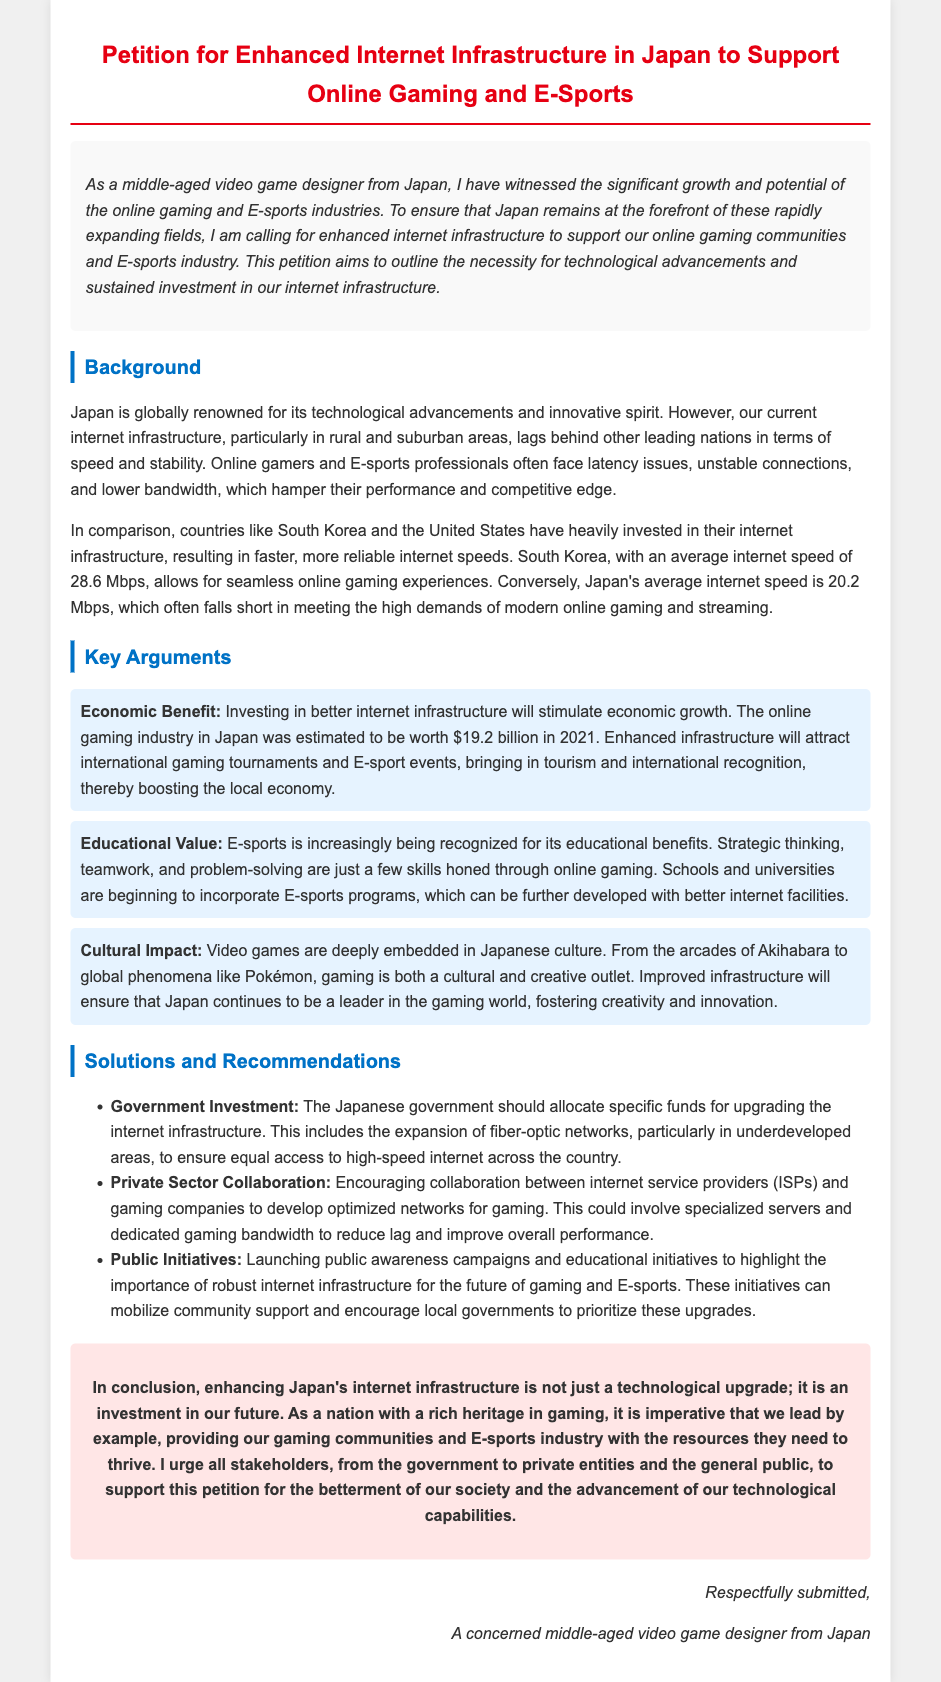What is the average internet speed in Japan? The document states that Japan's average internet speed is 20.2 Mbps, which often falls short in meeting the high demands of modern online gaming and streaming.
Answer: 20.2 Mbps What is the estimated worth of the online gaming industry in Japan in 2021? The petition mentions that the online gaming industry in Japan was estimated to be worth $19.2 billion in 2021.
Answer: $19.2 billion What country has an average internet speed of 28.6 Mbps? The document compares Japan's internet speed to South Korea, which has an average speed of 28.6 Mbps allowing for seamless online gaming experiences.
Answer: South Korea What are the three key arguments presented in the petition? The petition lists Economic Benefit, Educational Value, and Cultural Impact as the key arguments for enhancing internet infrastructure.
Answer: Economic Benefit, Educational Value, Cultural Impact What should the Japanese government allocate funds for? The petition calls for the government to allocate specific funds for upgrading the internet infrastructure, which includes expanding fiber-optic networks.
Answer: Upgrading internet infrastructure What type of collaboration is encouraged between ISPs and gaming companies? The document suggests that collaboration should focus on developing optimized networks for gaming, involving specialized servers and dedicated gaming bandwidth.
Answer: Optimized networks for gaming What is the overall conclusion of the petition? The conclusion emphasizes that enhancing Japan's internet infrastructure is an investment in the future and is crucial for leading in gaming.
Answer: Investment in our future Who submitted the petition? The petition is submitted by a concerned middle-aged video game designer from Japan.
Answer: A concerned middle-aged video game designer from Japan What is one recommended public initiative mentioned in the petition? The document mentions launching public awareness campaigns and educational initiatives about the importance of robust internet infrastructure.
Answer: Public awareness campaigns 